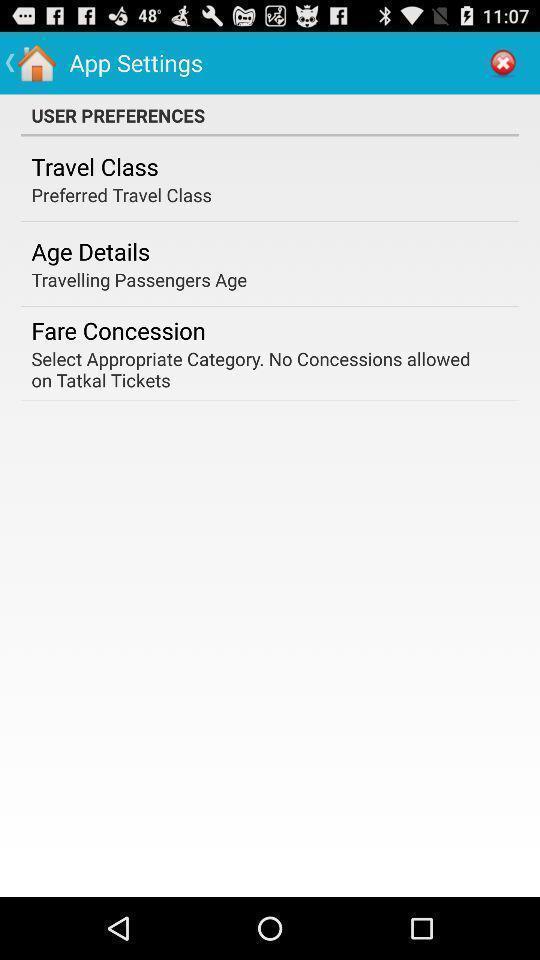Provide a detailed account of this screenshot. Settings page of a travel app. 